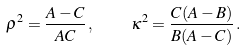<formula> <loc_0><loc_0><loc_500><loc_500>\rho ^ { 2 } = \frac { A - C } { A C } \, , \quad \kappa ^ { 2 } = \frac { C ( A - B ) } { B ( A - C ) } \, .</formula> 